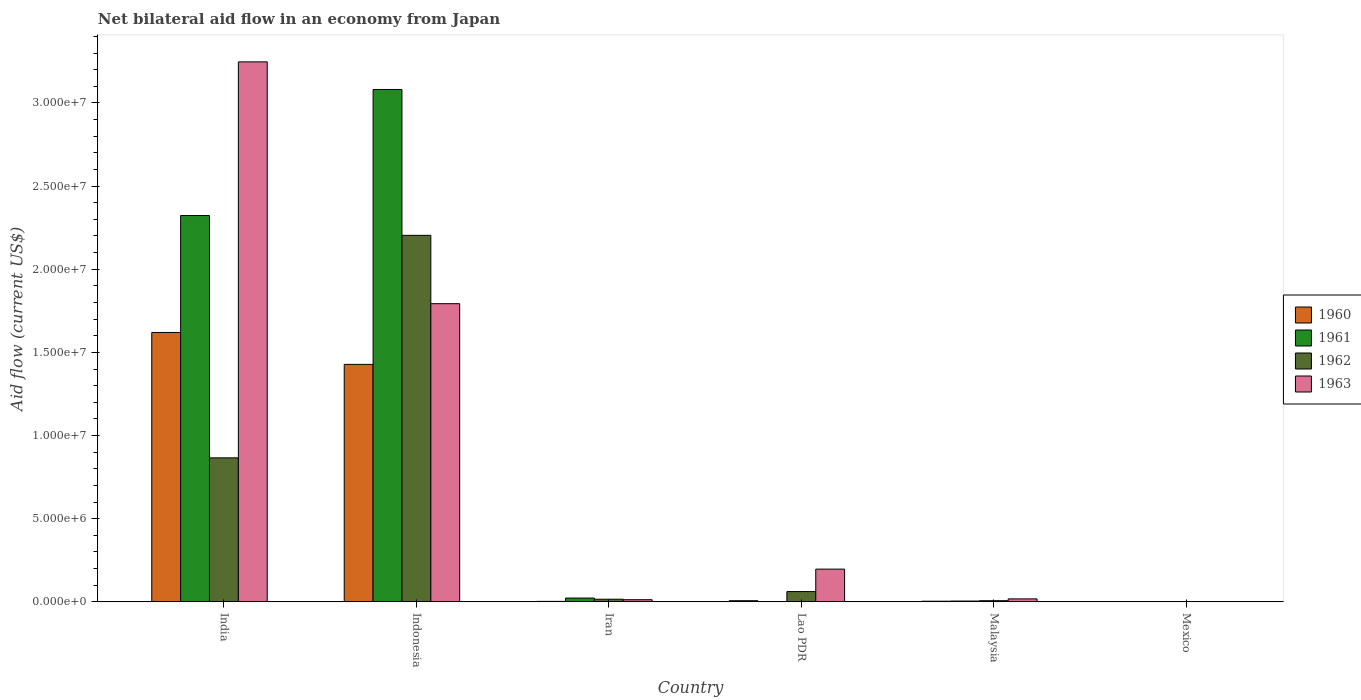How many groups of bars are there?
Offer a very short reply. 6. Are the number of bars per tick equal to the number of legend labels?
Provide a succinct answer. Yes. How many bars are there on the 3rd tick from the left?
Provide a short and direct response. 4. What is the label of the 3rd group of bars from the left?
Offer a terse response. Iran. In how many cases, is the number of bars for a given country not equal to the number of legend labels?
Ensure brevity in your answer.  0. What is the net bilateral aid flow in 1960 in Lao PDR?
Ensure brevity in your answer.  7.00e+04. Across all countries, what is the maximum net bilateral aid flow in 1963?
Your answer should be very brief. 3.25e+07. Across all countries, what is the minimum net bilateral aid flow in 1962?
Your response must be concise. 10000. In which country was the net bilateral aid flow in 1960 maximum?
Provide a short and direct response. India. In which country was the net bilateral aid flow in 1961 minimum?
Offer a very short reply. Lao PDR. What is the total net bilateral aid flow in 1962 in the graph?
Provide a succinct answer. 3.16e+07. What is the difference between the net bilateral aid flow in 1961 in Indonesia and that in Lao PDR?
Offer a terse response. 3.08e+07. What is the difference between the net bilateral aid flow in 1963 in Indonesia and the net bilateral aid flow in 1961 in India?
Provide a succinct answer. -5.30e+06. What is the average net bilateral aid flow in 1960 per country?
Provide a succinct answer. 5.10e+06. What is the difference between the net bilateral aid flow of/in 1962 and net bilateral aid flow of/in 1961 in India?
Ensure brevity in your answer.  -1.46e+07. In how many countries, is the net bilateral aid flow in 1962 greater than 17000000 US$?
Make the answer very short. 1. What is the ratio of the net bilateral aid flow in 1961 in Indonesia to that in Malaysia?
Your answer should be compact. 616.2. What is the difference between the highest and the second highest net bilateral aid flow in 1962?
Give a very brief answer. 1.34e+07. What is the difference between the highest and the lowest net bilateral aid flow in 1960?
Offer a terse response. 1.62e+07. In how many countries, is the net bilateral aid flow in 1961 greater than the average net bilateral aid flow in 1961 taken over all countries?
Provide a short and direct response. 2. Is the sum of the net bilateral aid flow in 1961 in India and Mexico greater than the maximum net bilateral aid flow in 1962 across all countries?
Provide a succinct answer. Yes. What does the 2nd bar from the left in Mexico represents?
Make the answer very short. 1961. Is it the case that in every country, the sum of the net bilateral aid flow in 1960 and net bilateral aid flow in 1962 is greater than the net bilateral aid flow in 1963?
Make the answer very short. No. How many bars are there?
Your response must be concise. 24. Are all the bars in the graph horizontal?
Offer a terse response. No. What is the difference between two consecutive major ticks on the Y-axis?
Your answer should be very brief. 5.00e+06. Does the graph contain grids?
Provide a short and direct response. No. How are the legend labels stacked?
Offer a terse response. Vertical. What is the title of the graph?
Your answer should be very brief. Net bilateral aid flow in an economy from Japan. Does "1976" appear as one of the legend labels in the graph?
Provide a short and direct response. No. What is the label or title of the X-axis?
Your answer should be compact. Country. What is the Aid flow (current US$) in 1960 in India?
Ensure brevity in your answer.  1.62e+07. What is the Aid flow (current US$) in 1961 in India?
Offer a very short reply. 2.32e+07. What is the Aid flow (current US$) of 1962 in India?
Make the answer very short. 8.66e+06. What is the Aid flow (current US$) in 1963 in India?
Provide a short and direct response. 3.25e+07. What is the Aid flow (current US$) of 1960 in Indonesia?
Offer a very short reply. 1.43e+07. What is the Aid flow (current US$) in 1961 in Indonesia?
Provide a short and direct response. 3.08e+07. What is the Aid flow (current US$) in 1962 in Indonesia?
Your answer should be very brief. 2.20e+07. What is the Aid flow (current US$) in 1963 in Indonesia?
Your answer should be compact. 1.79e+07. What is the Aid flow (current US$) in 1960 in Iran?
Your answer should be very brief. 3.00e+04. What is the Aid flow (current US$) of 1961 in Iran?
Give a very brief answer. 2.30e+05. What is the Aid flow (current US$) of 1960 in Lao PDR?
Give a very brief answer. 7.00e+04. What is the Aid flow (current US$) in 1961 in Lao PDR?
Your answer should be very brief. 10000. What is the Aid flow (current US$) in 1962 in Lao PDR?
Provide a succinct answer. 6.20e+05. What is the Aid flow (current US$) of 1963 in Lao PDR?
Offer a terse response. 1.97e+06. What is the Aid flow (current US$) of 1960 in Malaysia?
Provide a succinct answer. 4.00e+04. What is the Aid flow (current US$) of 1962 in Malaysia?
Your answer should be very brief. 7.00e+04. What is the Aid flow (current US$) in 1960 in Mexico?
Offer a terse response. 10000. What is the Aid flow (current US$) in 1961 in Mexico?
Make the answer very short. 10000. What is the Aid flow (current US$) in 1962 in Mexico?
Make the answer very short. 10000. What is the Aid flow (current US$) of 1963 in Mexico?
Your answer should be compact. 10000. Across all countries, what is the maximum Aid flow (current US$) in 1960?
Give a very brief answer. 1.62e+07. Across all countries, what is the maximum Aid flow (current US$) in 1961?
Make the answer very short. 3.08e+07. Across all countries, what is the maximum Aid flow (current US$) of 1962?
Make the answer very short. 2.20e+07. Across all countries, what is the maximum Aid flow (current US$) in 1963?
Ensure brevity in your answer.  3.25e+07. Across all countries, what is the minimum Aid flow (current US$) of 1960?
Your response must be concise. 10000. Across all countries, what is the minimum Aid flow (current US$) of 1961?
Give a very brief answer. 10000. Across all countries, what is the minimum Aid flow (current US$) of 1962?
Offer a terse response. 10000. What is the total Aid flow (current US$) in 1960 in the graph?
Offer a terse response. 3.06e+07. What is the total Aid flow (current US$) of 1961 in the graph?
Provide a succinct answer. 5.43e+07. What is the total Aid flow (current US$) in 1962 in the graph?
Your answer should be compact. 3.16e+07. What is the total Aid flow (current US$) of 1963 in the graph?
Provide a succinct answer. 5.27e+07. What is the difference between the Aid flow (current US$) of 1960 in India and that in Indonesia?
Provide a succinct answer. 1.92e+06. What is the difference between the Aid flow (current US$) in 1961 in India and that in Indonesia?
Make the answer very short. -7.58e+06. What is the difference between the Aid flow (current US$) of 1962 in India and that in Indonesia?
Ensure brevity in your answer.  -1.34e+07. What is the difference between the Aid flow (current US$) in 1963 in India and that in Indonesia?
Offer a terse response. 1.45e+07. What is the difference between the Aid flow (current US$) of 1960 in India and that in Iran?
Offer a terse response. 1.62e+07. What is the difference between the Aid flow (current US$) in 1961 in India and that in Iran?
Keep it short and to the point. 2.30e+07. What is the difference between the Aid flow (current US$) in 1962 in India and that in Iran?
Keep it short and to the point. 8.50e+06. What is the difference between the Aid flow (current US$) of 1963 in India and that in Iran?
Provide a succinct answer. 3.23e+07. What is the difference between the Aid flow (current US$) of 1960 in India and that in Lao PDR?
Provide a succinct answer. 1.61e+07. What is the difference between the Aid flow (current US$) in 1961 in India and that in Lao PDR?
Your answer should be very brief. 2.32e+07. What is the difference between the Aid flow (current US$) of 1962 in India and that in Lao PDR?
Offer a very short reply. 8.04e+06. What is the difference between the Aid flow (current US$) in 1963 in India and that in Lao PDR?
Ensure brevity in your answer.  3.05e+07. What is the difference between the Aid flow (current US$) in 1960 in India and that in Malaysia?
Make the answer very short. 1.62e+07. What is the difference between the Aid flow (current US$) in 1961 in India and that in Malaysia?
Make the answer very short. 2.32e+07. What is the difference between the Aid flow (current US$) in 1962 in India and that in Malaysia?
Provide a succinct answer. 8.59e+06. What is the difference between the Aid flow (current US$) of 1963 in India and that in Malaysia?
Give a very brief answer. 3.23e+07. What is the difference between the Aid flow (current US$) of 1960 in India and that in Mexico?
Your answer should be compact. 1.62e+07. What is the difference between the Aid flow (current US$) of 1961 in India and that in Mexico?
Provide a short and direct response. 2.32e+07. What is the difference between the Aid flow (current US$) of 1962 in India and that in Mexico?
Make the answer very short. 8.65e+06. What is the difference between the Aid flow (current US$) of 1963 in India and that in Mexico?
Offer a terse response. 3.25e+07. What is the difference between the Aid flow (current US$) in 1960 in Indonesia and that in Iran?
Your answer should be very brief. 1.42e+07. What is the difference between the Aid flow (current US$) in 1961 in Indonesia and that in Iran?
Your answer should be very brief. 3.06e+07. What is the difference between the Aid flow (current US$) of 1962 in Indonesia and that in Iran?
Offer a terse response. 2.19e+07. What is the difference between the Aid flow (current US$) of 1963 in Indonesia and that in Iran?
Your response must be concise. 1.78e+07. What is the difference between the Aid flow (current US$) in 1960 in Indonesia and that in Lao PDR?
Offer a very short reply. 1.42e+07. What is the difference between the Aid flow (current US$) in 1961 in Indonesia and that in Lao PDR?
Give a very brief answer. 3.08e+07. What is the difference between the Aid flow (current US$) in 1962 in Indonesia and that in Lao PDR?
Your answer should be compact. 2.14e+07. What is the difference between the Aid flow (current US$) in 1963 in Indonesia and that in Lao PDR?
Give a very brief answer. 1.60e+07. What is the difference between the Aid flow (current US$) of 1960 in Indonesia and that in Malaysia?
Make the answer very short. 1.42e+07. What is the difference between the Aid flow (current US$) in 1961 in Indonesia and that in Malaysia?
Your response must be concise. 3.08e+07. What is the difference between the Aid flow (current US$) of 1962 in Indonesia and that in Malaysia?
Provide a succinct answer. 2.20e+07. What is the difference between the Aid flow (current US$) of 1963 in Indonesia and that in Malaysia?
Offer a very short reply. 1.78e+07. What is the difference between the Aid flow (current US$) in 1960 in Indonesia and that in Mexico?
Provide a short and direct response. 1.43e+07. What is the difference between the Aid flow (current US$) of 1961 in Indonesia and that in Mexico?
Your answer should be compact. 3.08e+07. What is the difference between the Aid flow (current US$) in 1962 in Indonesia and that in Mexico?
Keep it short and to the point. 2.20e+07. What is the difference between the Aid flow (current US$) in 1963 in Indonesia and that in Mexico?
Make the answer very short. 1.79e+07. What is the difference between the Aid flow (current US$) in 1960 in Iran and that in Lao PDR?
Offer a very short reply. -4.00e+04. What is the difference between the Aid flow (current US$) in 1962 in Iran and that in Lao PDR?
Keep it short and to the point. -4.60e+05. What is the difference between the Aid flow (current US$) in 1963 in Iran and that in Lao PDR?
Give a very brief answer. -1.84e+06. What is the difference between the Aid flow (current US$) in 1960 in Iran and that in Malaysia?
Ensure brevity in your answer.  -10000. What is the difference between the Aid flow (current US$) in 1961 in Iran and that in Malaysia?
Offer a very short reply. 1.80e+05. What is the difference between the Aid flow (current US$) in 1963 in Iran and that in Malaysia?
Ensure brevity in your answer.  -5.00e+04. What is the difference between the Aid flow (current US$) in 1960 in Iran and that in Mexico?
Provide a succinct answer. 2.00e+04. What is the difference between the Aid flow (current US$) of 1962 in Iran and that in Mexico?
Provide a succinct answer. 1.50e+05. What is the difference between the Aid flow (current US$) of 1963 in Iran and that in Mexico?
Ensure brevity in your answer.  1.20e+05. What is the difference between the Aid flow (current US$) in 1960 in Lao PDR and that in Malaysia?
Provide a succinct answer. 3.00e+04. What is the difference between the Aid flow (current US$) in 1961 in Lao PDR and that in Malaysia?
Your answer should be compact. -4.00e+04. What is the difference between the Aid flow (current US$) of 1962 in Lao PDR and that in Malaysia?
Make the answer very short. 5.50e+05. What is the difference between the Aid flow (current US$) in 1963 in Lao PDR and that in Malaysia?
Your response must be concise. 1.79e+06. What is the difference between the Aid flow (current US$) of 1960 in Lao PDR and that in Mexico?
Your response must be concise. 6.00e+04. What is the difference between the Aid flow (current US$) of 1962 in Lao PDR and that in Mexico?
Offer a very short reply. 6.10e+05. What is the difference between the Aid flow (current US$) of 1963 in Lao PDR and that in Mexico?
Make the answer very short. 1.96e+06. What is the difference between the Aid flow (current US$) of 1960 in Malaysia and that in Mexico?
Make the answer very short. 3.00e+04. What is the difference between the Aid flow (current US$) of 1962 in Malaysia and that in Mexico?
Provide a succinct answer. 6.00e+04. What is the difference between the Aid flow (current US$) of 1963 in Malaysia and that in Mexico?
Make the answer very short. 1.70e+05. What is the difference between the Aid flow (current US$) of 1960 in India and the Aid flow (current US$) of 1961 in Indonesia?
Make the answer very short. -1.46e+07. What is the difference between the Aid flow (current US$) in 1960 in India and the Aid flow (current US$) in 1962 in Indonesia?
Your answer should be compact. -5.84e+06. What is the difference between the Aid flow (current US$) of 1960 in India and the Aid flow (current US$) of 1963 in Indonesia?
Your answer should be very brief. -1.73e+06. What is the difference between the Aid flow (current US$) in 1961 in India and the Aid flow (current US$) in 1962 in Indonesia?
Make the answer very short. 1.19e+06. What is the difference between the Aid flow (current US$) in 1961 in India and the Aid flow (current US$) in 1963 in Indonesia?
Ensure brevity in your answer.  5.30e+06. What is the difference between the Aid flow (current US$) in 1962 in India and the Aid flow (current US$) in 1963 in Indonesia?
Provide a short and direct response. -9.27e+06. What is the difference between the Aid flow (current US$) of 1960 in India and the Aid flow (current US$) of 1961 in Iran?
Ensure brevity in your answer.  1.60e+07. What is the difference between the Aid flow (current US$) of 1960 in India and the Aid flow (current US$) of 1962 in Iran?
Your answer should be compact. 1.60e+07. What is the difference between the Aid flow (current US$) of 1960 in India and the Aid flow (current US$) of 1963 in Iran?
Give a very brief answer. 1.61e+07. What is the difference between the Aid flow (current US$) in 1961 in India and the Aid flow (current US$) in 1962 in Iran?
Keep it short and to the point. 2.31e+07. What is the difference between the Aid flow (current US$) in 1961 in India and the Aid flow (current US$) in 1963 in Iran?
Ensure brevity in your answer.  2.31e+07. What is the difference between the Aid flow (current US$) of 1962 in India and the Aid flow (current US$) of 1963 in Iran?
Your answer should be very brief. 8.53e+06. What is the difference between the Aid flow (current US$) in 1960 in India and the Aid flow (current US$) in 1961 in Lao PDR?
Provide a succinct answer. 1.62e+07. What is the difference between the Aid flow (current US$) in 1960 in India and the Aid flow (current US$) in 1962 in Lao PDR?
Ensure brevity in your answer.  1.56e+07. What is the difference between the Aid flow (current US$) of 1960 in India and the Aid flow (current US$) of 1963 in Lao PDR?
Provide a succinct answer. 1.42e+07. What is the difference between the Aid flow (current US$) in 1961 in India and the Aid flow (current US$) in 1962 in Lao PDR?
Provide a short and direct response. 2.26e+07. What is the difference between the Aid flow (current US$) of 1961 in India and the Aid flow (current US$) of 1963 in Lao PDR?
Make the answer very short. 2.13e+07. What is the difference between the Aid flow (current US$) in 1962 in India and the Aid flow (current US$) in 1963 in Lao PDR?
Make the answer very short. 6.69e+06. What is the difference between the Aid flow (current US$) in 1960 in India and the Aid flow (current US$) in 1961 in Malaysia?
Give a very brief answer. 1.62e+07. What is the difference between the Aid flow (current US$) in 1960 in India and the Aid flow (current US$) in 1962 in Malaysia?
Keep it short and to the point. 1.61e+07. What is the difference between the Aid flow (current US$) of 1960 in India and the Aid flow (current US$) of 1963 in Malaysia?
Your response must be concise. 1.60e+07. What is the difference between the Aid flow (current US$) in 1961 in India and the Aid flow (current US$) in 1962 in Malaysia?
Your answer should be compact. 2.32e+07. What is the difference between the Aid flow (current US$) of 1961 in India and the Aid flow (current US$) of 1963 in Malaysia?
Keep it short and to the point. 2.30e+07. What is the difference between the Aid flow (current US$) in 1962 in India and the Aid flow (current US$) in 1963 in Malaysia?
Offer a terse response. 8.48e+06. What is the difference between the Aid flow (current US$) of 1960 in India and the Aid flow (current US$) of 1961 in Mexico?
Keep it short and to the point. 1.62e+07. What is the difference between the Aid flow (current US$) in 1960 in India and the Aid flow (current US$) in 1962 in Mexico?
Your answer should be very brief. 1.62e+07. What is the difference between the Aid flow (current US$) of 1960 in India and the Aid flow (current US$) of 1963 in Mexico?
Give a very brief answer. 1.62e+07. What is the difference between the Aid flow (current US$) of 1961 in India and the Aid flow (current US$) of 1962 in Mexico?
Make the answer very short. 2.32e+07. What is the difference between the Aid flow (current US$) of 1961 in India and the Aid flow (current US$) of 1963 in Mexico?
Your answer should be very brief. 2.32e+07. What is the difference between the Aid flow (current US$) in 1962 in India and the Aid flow (current US$) in 1963 in Mexico?
Your answer should be very brief. 8.65e+06. What is the difference between the Aid flow (current US$) in 1960 in Indonesia and the Aid flow (current US$) in 1961 in Iran?
Provide a succinct answer. 1.40e+07. What is the difference between the Aid flow (current US$) in 1960 in Indonesia and the Aid flow (current US$) in 1962 in Iran?
Your answer should be very brief. 1.41e+07. What is the difference between the Aid flow (current US$) of 1960 in Indonesia and the Aid flow (current US$) of 1963 in Iran?
Give a very brief answer. 1.42e+07. What is the difference between the Aid flow (current US$) in 1961 in Indonesia and the Aid flow (current US$) in 1962 in Iran?
Offer a terse response. 3.06e+07. What is the difference between the Aid flow (current US$) of 1961 in Indonesia and the Aid flow (current US$) of 1963 in Iran?
Give a very brief answer. 3.07e+07. What is the difference between the Aid flow (current US$) in 1962 in Indonesia and the Aid flow (current US$) in 1963 in Iran?
Your response must be concise. 2.19e+07. What is the difference between the Aid flow (current US$) of 1960 in Indonesia and the Aid flow (current US$) of 1961 in Lao PDR?
Give a very brief answer. 1.43e+07. What is the difference between the Aid flow (current US$) of 1960 in Indonesia and the Aid flow (current US$) of 1962 in Lao PDR?
Your response must be concise. 1.37e+07. What is the difference between the Aid flow (current US$) of 1960 in Indonesia and the Aid flow (current US$) of 1963 in Lao PDR?
Make the answer very short. 1.23e+07. What is the difference between the Aid flow (current US$) in 1961 in Indonesia and the Aid flow (current US$) in 1962 in Lao PDR?
Offer a very short reply. 3.02e+07. What is the difference between the Aid flow (current US$) in 1961 in Indonesia and the Aid flow (current US$) in 1963 in Lao PDR?
Make the answer very short. 2.88e+07. What is the difference between the Aid flow (current US$) of 1962 in Indonesia and the Aid flow (current US$) of 1963 in Lao PDR?
Offer a very short reply. 2.01e+07. What is the difference between the Aid flow (current US$) of 1960 in Indonesia and the Aid flow (current US$) of 1961 in Malaysia?
Your answer should be very brief. 1.42e+07. What is the difference between the Aid flow (current US$) in 1960 in Indonesia and the Aid flow (current US$) in 1962 in Malaysia?
Your answer should be very brief. 1.42e+07. What is the difference between the Aid flow (current US$) in 1960 in Indonesia and the Aid flow (current US$) in 1963 in Malaysia?
Give a very brief answer. 1.41e+07. What is the difference between the Aid flow (current US$) of 1961 in Indonesia and the Aid flow (current US$) of 1962 in Malaysia?
Provide a succinct answer. 3.07e+07. What is the difference between the Aid flow (current US$) in 1961 in Indonesia and the Aid flow (current US$) in 1963 in Malaysia?
Offer a very short reply. 3.06e+07. What is the difference between the Aid flow (current US$) of 1962 in Indonesia and the Aid flow (current US$) of 1963 in Malaysia?
Your answer should be very brief. 2.19e+07. What is the difference between the Aid flow (current US$) of 1960 in Indonesia and the Aid flow (current US$) of 1961 in Mexico?
Provide a succinct answer. 1.43e+07. What is the difference between the Aid flow (current US$) in 1960 in Indonesia and the Aid flow (current US$) in 1962 in Mexico?
Provide a succinct answer. 1.43e+07. What is the difference between the Aid flow (current US$) in 1960 in Indonesia and the Aid flow (current US$) in 1963 in Mexico?
Your response must be concise. 1.43e+07. What is the difference between the Aid flow (current US$) of 1961 in Indonesia and the Aid flow (current US$) of 1962 in Mexico?
Keep it short and to the point. 3.08e+07. What is the difference between the Aid flow (current US$) in 1961 in Indonesia and the Aid flow (current US$) in 1963 in Mexico?
Ensure brevity in your answer.  3.08e+07. What is the difference between the Aid flow (current US$) of 1962 in Indonesia and the Aid flow (current US$) of 1963 in Mexico?
Offer a very short reply. 2.20e+07. What is the difference between the Aid flow (current US$) in 1960 in Iran and the Aid flow (current US$) in 1962 in Lao PDR?
Make the answer very short. -5.90e+05. What is the difference between the Aid flow (current US$) of 1960 in Iran and the Aid flow (current US$) of 1963 in Lao PDR?
Your answer should be compact. -1.94e+06. What is the difference between the Aid flow (current US$) in 1961 in Iran and the Aid flow (current US$) in 1962 in Lao PDR?
Give a very brief answer. -3.90e+05. What is the difference between the Aid flow (current US$) in 1961 in Iran and the Aid flow (current US$) in 1963 in Lao PDR?
Provide a succinct answer. -1.74e+06. What is the difference between the Aid flow (current US$) in 1962 in Iran and the Aid flow (current US$) in 1963 in Lao PDR?
Provide a short and direct response. -1.81e+06. What is the difference between the Aid flow (current US$) in 1961 in Iran and the Aid flow (current US$) in 1963 in Mexico?
Keep it short and to the point. 2.20e+05. What is the difference between the Aid flow (current US$) of 1960 in Lao PDR and the Aid flow (current US$) of 1962 in Malaysia?
Provide a short and direct response. 0. What is the difference between the Aid flow (current US$) in 1961 in Lao PDR and the Aid flow (current US$) in 1963 in Malaysia?
Make the answer very short. -1.70e+05. What is the difference between the Aid flow (current US$) of 1960 in Lao PDR and the Aid flow (current US$) of 1961 in Mexico?
Ensure brevity in your answer.  6.00e+04. What is the difference between the Aid flow (current US$) in 1960 in Lao PDR and the Aid flow (current US$) in 1962 in Mexico?
Keep it short and to the point. 6.00e+04. What is the difference between the Aid flow (current US$) of 1960 in Lao PDR and the Aid flow (current US$) of 1963 in Mexico?
Make the answer very short. 6.00e+04. What is the difference between the Aid flow (current US$) of 1961 in Lao PDR and the Aid flow (current US$) of 1962 in Mexico?
Your answer should be compact. 0. What is the difference between the Aid flow (current US$) of 1961 in Lao PDR and the Aid flow (current US$) of 1963 in Mexico?
Give a very brief answer. 0. What is the difference between the Aid flow (current US$) of 1962 in Lao PDR and the Aid flow (current US$) of 1963 in Mexico?
Provide a succinct answer. 6.10e+05. What is the difference between the Aid flow (current US$) in 1960 in Malaysia and the Aid flow (current US$) in 1961 in Mexico?
Your answer should be compact. 3.00e+04. What is the difference between the Aid flow (current US$) of 1960 in Malaysia and the Aid flow (current US$) of 1962 in Mexico?
Ensure brevity in your answer.  3.00e+04. What is the difference between the Aid flow (current US$) of 1960 in Malaysia and the Aid flow (current US$) of 1963 in Mexico?
Make the answer very short. 3.00e+04. What is the difference between the Aid flow (current US$) of 1962 in Malaysia and the Aid flow (current US$) of 1963 in Mexico?
Provide a succinct answer. 6.00e+04. What is the average Aid flow (current US$) in 1960 per country?
Your response must be concise. 5.10e+06. What is the average Aid flow (current US$) of 1961 per country?
Ensure brevity in your answer.  9.06e+06. What is the average Aid flow (current US$) in 1962 per country?
Ensure brevity in your answer.  5.26e+06. What is the average Aid flow (current US$) in 1963 per country?
Your answer should be very brief. 8.78e+06. What is the difference between the Aid flow (current US$) of 1960 and Aid flow (current US$) of 1961 in India?
Offer a very short reply. -7.03e+06. What is the difference between the Aid flow (current US$) of 1960 and Aid flow (current US$) of 1962 in India?
Your answer should be compact. 7.54e+06. What is the difference between the Aid flow (current US$) in 1960 and Aid flow (current US$) in 1963 in India?
Offer a terse response. -1.63e+07. What is the difference between the Aid flow (current US$) in 1961 and Aid flow (current US$) in 1962 in India?
Make the answer very short. 1.46e+07. What is the difference between the Aid flow (current US$) in 1961 and Aid flow (current US$) in 1963 in India?
Offer a very short reply. -9.24e+06. What is the difference between the Aid flow (current US$) in 1962 and Aid flow (current US$) in 1963 in India?
Your answer should be very brief. -2.38e+07. What is the difference between the Aid flow (current US$) of 1960 and Aid flow (current US$) of 1961 in Indonesia?
Your response must be concise. -1.65e+07. What is the difference between the Aid flow (current US$) of 1960 and Aid flow (current US$) of 1962 in Indonesia?
Your answer should be compact. -7.76e+06. What is the difference between the Aid flow (current US$) in 1960 and Aid flow (current US$) in 1963 in Indonesia?
Offer a terse response. -3.65e+06. What is the difference between the Aid flow (current US$) in 1961 and Aid flow (current US$) in 1962 in Indonesia?
Provide a succinct answer. 8.77e+06. What is the difference between the Aid flow (current US$) in 1961 and Aid flow (current US$) in 1963 in Indonesia?
Make the answer very short. 1.29e+07. What is the difference between the Aid flow (current US$) of 1962 and Aid flow (current US$) of 1963 in Indonesia?
Give a very brief answer. 4.11e+06. What is the difference between the Aid flow (current US$) of 1960 and Aid flow (current US$) of 1962 in Iran?
Keep it short and to the point. -1.30e+05. What is the difference between the Aid flow (current US$) in 1960 and Aid flow (current US$) in 1962 in Lao PDR?
Give a very brief answer. -5.50e+05. What is the difference between the Aid flow (current US$) of 1960 and Aid flow (current US$) of 1963 in Lao PDR?
Provide a succinct answer. -1.90e+06. What is the difference between the Aid flow (current US$) of 1961 and Aid flow (current US$) of 1962 in Lao PDR?
Ensure brevity in your answer.  -6.10e+05. What is the difference between the Aid flow (current US$) of 1961 and Aid flow (current US$) of 1963 in Lao PDR?
Your response must be concise. -1.96e+06. What is the difference between the Aid flow (current US$) in 1962 and Aid flow (current US$) in 1963 in Lao PDR?
Your response must be concise. -1.35e+06. What is the difference between the Aid flow (current US$) of 1960 and Aid flow (current US$) of 1961 in Malaysia?
Offer a terse response. -10000. What is the difference between the Aid flow (current US$) of 1960 and Aid flow (current US$) of 1962 in Malaysia?
Make the answer very short. -3.00e+04. What is the difference between the Aid flow (current US$) of 1961 and Aid flow (current US$) of 1963 in Malaysia?
Give a very brief answer. -1.30e+05. What is the difference between the Aid flow (current US$) in 1960 and Aid flow (current US$) in 1962 in Mexico?
Provide a short and direct response. 0. What is the difference between the Aid flow (current US$) in 1960 and Aid flow (current US$) in 1963 in Mexico?
Make the answer very short. 0. What is the difference between the Aid flow (current US$) in 1961 and Aid flow (current US$) in 1963 in Mexico?
Your answer should be compact. 0. What is the difference between the Aid flow (current US$) of 1962 and Aid flow (current US$) of 1963 in Mexico?
Offer a terse response. 0. What is the ratio of the Aid flow (current US$) of 1960 in India to that in Indonesia?
Your answer should be compact. 1.13. What is the ratio of the Aid flow (current US$) in 1961 in India to that in Indonesia?
Ensure brevity in your answer.  0.75. What is the ratio of the Aid flow (current US$) of 1962 in India to that in Indonesia?
Offer a very short reply. 0.39. What is the ratio of the Aid flow (current US$) in 1963 in India to that in Indonesia?
Your answer should be compact. 1.81. What is the ratio of the Aid flow (current US$) of 1960 in India to that in Iran?
Give a very brief answer. 540. What is the ratio of the Aid flow (current US$) of 1961 in India to that in Iran?
Ensure brevity in your answer.  101. What is the ratio of the Aid flow (current US$) of 1962 in India to that in Iran?
Ensure brevity in your answer.  54.12. What is the ratio of the Aid flow (current US$) of 1963 in India to that in Iran?
Give a very brief answer. 249.77. What is the ratio of the Aid flow (current US$) of 1960 in India to that in Lao PDR?
Your answer should be very brief. 231.43. What is the ratio of the Aid flow (current US$) in 1961 in India to that in Lao PDR?
Offer a terse response. 2323. What is the ratio of the Aid flow (current US$) in 1962 in India to that in Lao PDR?
Provide a succinct answer. 13.97. What is the ratio of the Aid flow (current US$) of 1963 in India to that in Lao PDR?
Provide a short and direct response. 16.48. What is the ratio of the Aid flow (current US$) in 1960 in India to that in Malaysia?
Give a very brief answer. 405. What is the ratio of the Aid flow (current US$) in 1961 in India to that in Malaysia?
Offer a terse response. 464.6. What is the ratio of the Aid flow (current US$) in 1962 in India to that in Malaysia?
Ensure brevity in your answer.  123.71. What is the ratio of the Aid flow (current US$) of 1963 in India to that in Malaysia?
Your response must be concise. 180.39. What is the ratio of the Aid flow (current US$) in 1960 in India to that in Mexico?
Offer a very short reply. 1620. What is the ratio of the Aid flow (current US$) of 1961 in India to that in Mexico?
Make the answer very short. 2323. What is the ratio of the Aid flow (current US$) of 1962 in India to that in Mexico?
Provide a short and direct response. 866. What is the ratio of the Aid flow (current US$) in 1963 in India to that in Mexico?
Provide a short and direct response. 3247. What is the ratio of the Aid flow (current US$) of 1960 in Indonesia to that in Iran?
Provide a short and direct response. 476. What is the ratio of the Aid flow (current US$) of 1961 in Indonesia to that in Iran?
Offer a very short reply. 133.96. What is the ratio of the Aid flow (current US$) in 1962 in Indonesia to that in Iran?
Your answer should be very brief. 137.75. What is the ratio of the Aid flow (current US$) in 1963 in Indonesia to that in Iran?
Your answer should be compact. 137.92. What is the ratio of the Aid flow (current US$) of 1960 in Indonesia to that in Lao PDR?
Provide a short and direct response. 204. What is the ratio of the Aid flow (current US$) in 1961 in Indonesia to that in Lao PDR?
Offer a very short reply. 3081. What is the ratio of the Aid flow (current US$) in 1962 in Indonesia to that in Lao PDR?
Your response must be concise. 35.55. What is the ratio of the Aid flow (current US$) in 1963 in Indonesia to that in Lao PDR?
Keep it short and to the point. 9.1. What is the ratio of the Aid flow (current US$) of 1960 in Indonesia to that in Malaysia?
Provide a succinct answer. 357. What is the ratio of the Aid flow (current US$) of 1961 in Indonesia to that in Malaysia?
Give a very brief answer. 616.2. What is the ratio of the Aid flow (current US$) in 1962 in Indonesia to that in Malaysia?
Give a very brief answer. 314.86. What is the ratio of the Aid flow (current US$) in 1963 in Indonesia to that in Malaysia?
Provide a succinct answer. 99.61. What is the ratio of the Aid flow (current US$) of 1960 in Indonesia to that in Mexico?
Make the answer very short. 1428. What is the ratio of the Aid flow (current US$) in 1961 in Indonesia to that in Mexico?
Offer a very short reply. 3081. What is the ratio of the Aid flow (current US$) of 1962 in Indonesia to that in Mexico?
Your response must be concise. 2204. What is the ratio of the Aid flow (current US$) in 1963 in Indonesia to that in Mexico?
Offer a very short reply. 1793. What is the ratio of the Aid flow (current US$) in 1960 in Iran to that in Lao PDR?
Your answer should be compact. 0.43. What is the ratio of the Aid flow (current US$) in 1961 in Iran to that in Lao PDR?
Keep it short and to the point. 23. What is the ratio of the Aid flow (current US$) in 1962 in Iran to that in Lao PDR?
Offer a terse response. 0.26. What is the ratio of the Aid flow (current US$) of 1963 in Iran to that in Lao PDR?
Provide a short and direct response. 0.07. What is the ratio of the Aid flow (current US$) of 1962 in Iran to that in Malaysia?
Make the answer very short. 2.29. What is the ratio of the Aid flow (current US$) of 1963 in Iran to that in Malaysia?
Make the answer very short. 0.72. What is the ratio of the Aid flow (current US$) in 1960 in Iran to that in Mexico?
Offer a very short reply. 3. What is the ratio of the Aid flow (current US$) of 1962 in Iran to that in Mexico?
Keep it short and to the point. 16. What is the ratio of the Aid flow (current US$) of 1962 in Lao PDR to that in Malaysia?
Offer a terse response. 8.86. What is the ratio of the Aid flow (current US$) of 1963 in Lao PDR to that in Malaysia?
Make the answer very short. 10.94. What is the ratio of the Aid flow (current US$) of 1963 in Lao PDR to that in Mexico?
Offer a very short reply. 197. What is the ratio of the Aid flow (current US$) of 1960 in Malaysia to that in Mexico?
Provide a short and direct response. 4. What is the ratio of the Aid flow (current US$) in 1961 in Malaysia to that in Mexico?
Make the answer very short. 5. What is the ratio of the Aid flow (current US$) of 1962 in Malaysia to that in Mexico?
Your answer should be compact. 7. What is the difference between the highest and the second highest Aid flow (current US$) of 1960?
Make the answer very short. 1.92e+06. What is the difference between the highest and the second highest Aid flow (current US$) of 1961?
Keep it short and to the point. 7.58e+06. What is the difference between the highest and the second highest Aid flow (current US$) of 1962?
Make the answer very short. 1.34e+07. What is the difference between the highest and the second highest Aid flow (current US$) of 1963?
Your answer should be compact. 1.45e+07. What is the difference between the highest and the lowest Aid flow (current US$) of 1960?
Keep it short and to the point. 1.62e+07. What is the difference between the highest and the lowest Aid flow (current US$) in 1961?
Make the answer very short. 3.08e+07. What is the difference between the highest and the lowest Aid flow (current US$) of 1962?
Provide a short and direct response. 2.20e+07. What is the difference between the highest and the lowest Aid flow (current US$) of 1963?
Offer a terse response. 3.25e+07. 